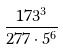<formula> <loc_0><loc_0><loc_500><loc_500>\frac { 1 7 3 ^ { 3 } } { 2 7 7 \cdot 5 ^ { 6 } }</formula> 